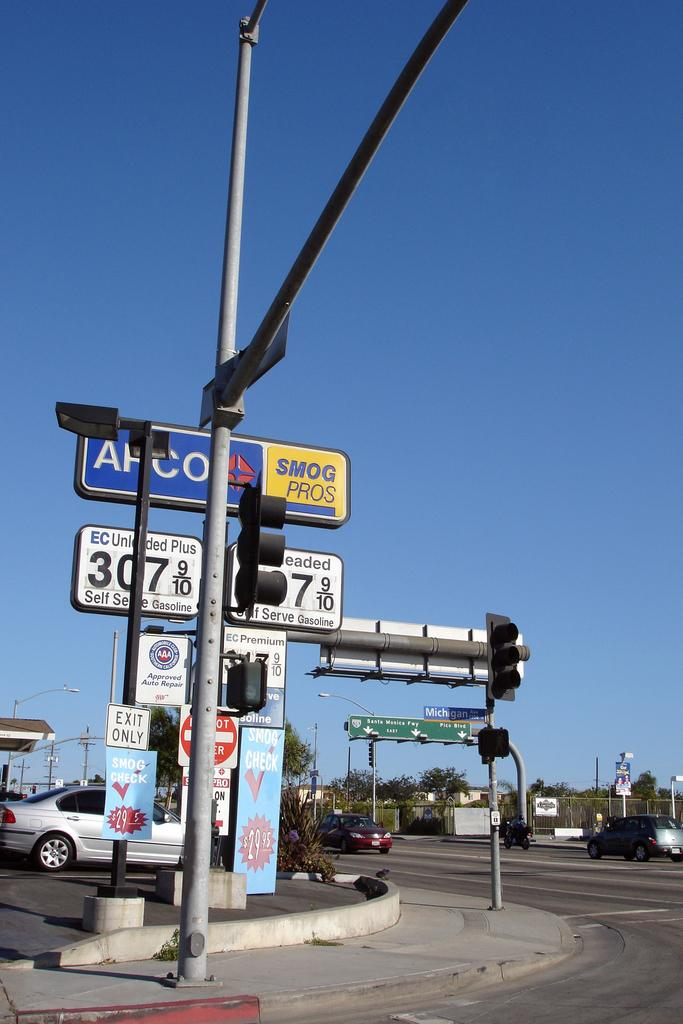What type of vegetation can be seen in the image? There are trees in the image. What structures are present in the image? There are poles, traffic signals, sign boards, boards, and light poles in the image. What type of fencing is visible in the image? There is net fencing in the image. What is happening on the road in the image? There are vehicles on the road in the image. What is the color of the sky in the image? The sky is blue in the image. Can you see any hands holding an apple in the image? There are no hands or apples present in the image. Are there any insects visible on the trees in the image? There are no insects visible on the trees in the image. 